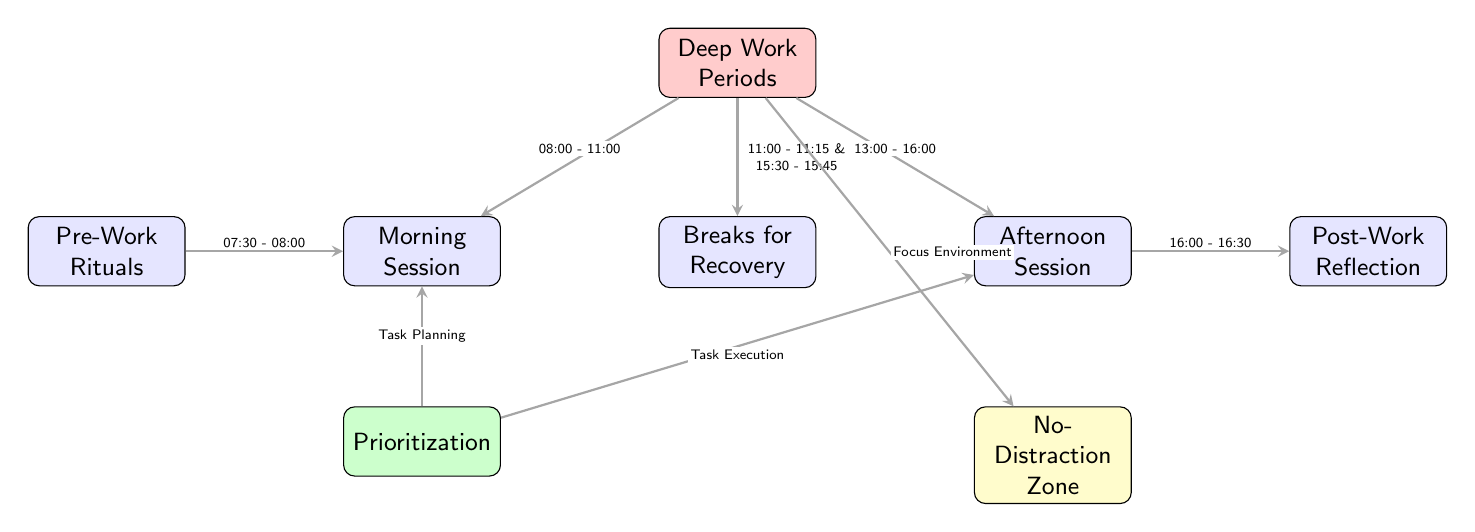What are the time slots allocated for the morning session? The diagram indicates that the morning session takes place from 08:00 to 11:00. This is clearly labeled on the arrow from the "Deep Work Periods" node to the "Morning Session" node.
Answer: 08:00 - 11:00 How many deep work periods are represented in the diagram? The diagram outlines two distinct deep work periods: the morning session and the afternoon session, both connected to the "Deep Work Periods" node. Thus, there are two periods.
Answer: 2 What activity precedes the morning deep work session? The diagram shows that "Pre-Work Rituals" occur before the morning deep work session, with an arrow pointing from "Pre-Work Rituals" to the "Morning Session" indicating this sequence.
Answer: Pre-Work Rituals What is the duration of the post-work reflection activity? The diagram depicts the post-work reflection starting immediately after the afternoon session, from 16:00 to 16:30. This is represented by the arrow connecting the "Afternoon Session" to "Post-Work Reflection."
Answer: 30 minutes Which nodes are directly linked to the "Breaks for Recovery"? The diagram outlines two direct connections to the "Breaks for Recovery" node from the "Deep Work Periods" node, indicating break times after the morning and afternoon sessions, thus linking it to both deep work sessions.
Answer: 2 What kind of environment is emphasized for effective deep work? The diagram signifies the necessity of a "No-Distraction Zone" as part of the deep work strategy, specifically noted by an arrow leading from "Deep Work Periods" to "No-Distraction Zone."
Answer: No-Distraction Zone What are the activities specified for the prioritization node? The diagram shows two activities for the "Prioritization" node: "Task Planning" is associated with the morning session and "Task Execution" is associated with the afternoon session, both illustrated by arrows leading from the "Prioritization" node to the respective work periods.
Answer: Task Planning, Task Execution In which part does the recovery break occur after the morning session? The recovery break occurs between 11:00 and 11:15, as indicated by the arrow leading from the "Deep Work Periods" to the "Breaks for Recovery," denoting the first recovery break after the morning session.
Answer: 11:00 - 11:15 